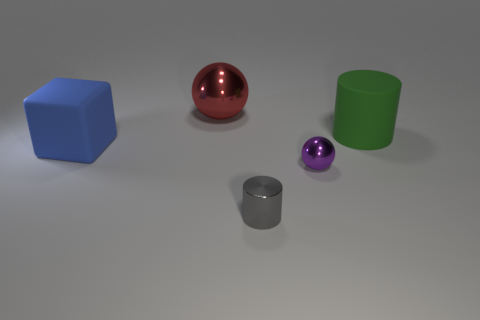There is a shiny thing that is the same size as the blue cube; what is its shape?
Give a very brief answer. Sphere. What is the size of the thing that is both behind the matte cube and on the left side of the tiny purple metallic thing?
Make the answer very short. Large. Are there any shiny things of the same size as the gray cylinder?
Offer a very short reply. Yes. Are there more big red objects that are to the left of the green object than metal balls right of the tiny ball?
Your response must be concise. Yes. Are the red thing and the large thing that is to the left of the red ball made of the same material?
Your answer should be very brief. No. There is a big matte object that is to the right of the shiny thing in front of the tiny purple shiny sphere; what number of large matte things are in front of it?
Offer a terse response. 1. Do the big red metal object and the big thing in front of the green matte cylinder have the same shape?
Keep it short and to the point. No. The object that is to the left of the gray object and in front of the big green matte cylinder is what color?
Make the answer very short. Blue. What is the material of the small thing in front of the metal ball that is in front of the metallic thing that is behind the matte cylinder?
Ensure brevity in your answer.  Metal. What is the material of the purple ball?
Your answer should be very brief. Metal. 